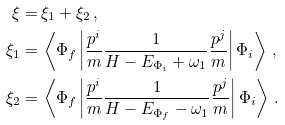Convert formula to latex. <formula><loc_0><loc_0><loc_500><loc_500>\xi = & \, \xi _ { 1 } + \xi _ { 2 } \, , \\ \xi _ { 1 } = & \, \left < \Phi _ { f } \left | \frac { p ^ { i } } { m } \frac { 1 } { H - E _ { \Phi _ { i } } + \omega _ { 1 } } \frac { p ^ { j } } { m } \right | \Phi _ { i } \right > \, , \\ \xi _ { 2 } = & \, \left < \Phi _ { f } \left | \frac { p ^ { i } } { m } \frac { 1 } { H - E _ { \Phi _ { f } } - \omega _ { 1 } } \frac { p ^ { j } } { m } \right | \Phi _ { i } \right > \, .</formula> 